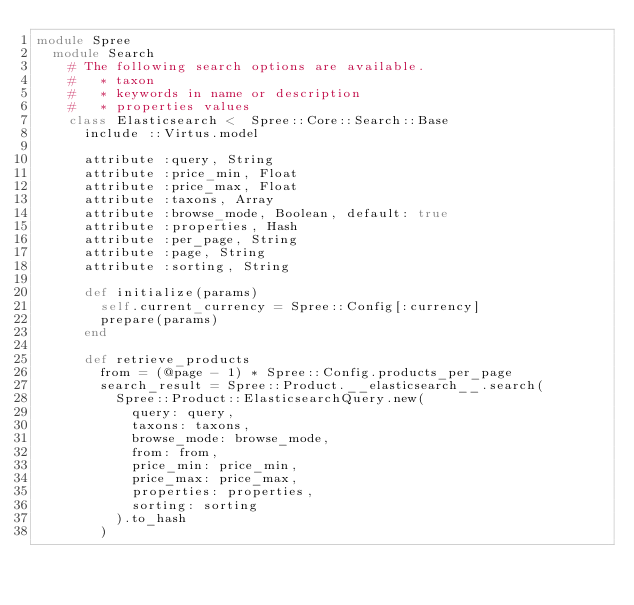<code> <loc_0><loc_0><loc_500><loc_500><_Ruby_>module Spree
  module Search
    # The following search options are available.
    #   * taxon
    #   * keywords in name or description
    #   * properties values
    class Elasticsearch <  Spree::Core::Search::Base
      include ::Virtus.model

      attribute :query, String
      attribute :price_min, Float
      attribute :price_max, Float
      attribute :taxons, Array
      attribute :browse_mode, Boolean, default: true
      attribute :properties, Hash
      attribute :per_page, String
      attribute :page, String
      attribute :sorting, String

      def initialize(params)
        self.current_currency = Spree::Config[:currency]
        prepare(params)
      end

      def retrieve_products
        from = (@page - 1) * Spree::Config.products_per_page
        search_result = Spree::Product.__elasticsearch__.search(
          Spree::Product::ElasticsearchQuery.new(
            query: query,
            taxons: taxons,
            browse_mode: browse_mode,
            from: from,
            price_min: price_min,
            price_max: price_max,
            properties: properties,
            sorting: sorting
          ).to_hash
        )</code> 